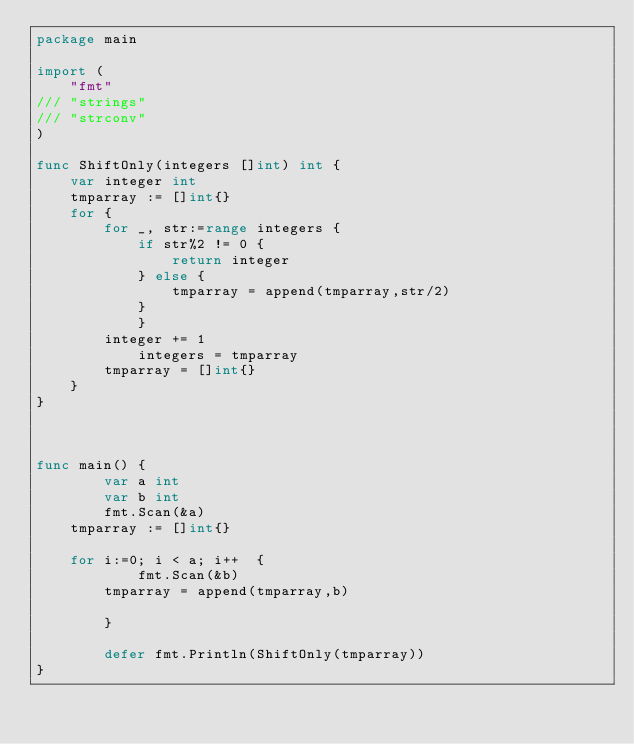Convert code to text. <code><loc_0><loc_0><loc_500><loc_500><_Go_>package main

import (
	"fmt"
///	"strings"
///	"strconv"
)

func ShiftOnly(integers []int) int {
	var integer int
	tmparray := []int{}
	for {
		for _, str:=range integers {
			if str%2 != 0 {
				return integer
			} else {
				tmparray = append(tmparray,str/2)
			}
        	}
		integer += 1
	        integers = tmparray	
		tmparray = []int{}
	}	
}



func main() {
        var a int
        var b int
        fmt.Scan(&a)
	tmparray := []int{}
        
	for i:=0; i < a; i++  {
        	fmt.Scan(&b)
		tmparray = append(tmparray,b)

        }

        defer fmt.Println(ShiftOnly(tmparray))
}</code> 